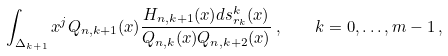<formula> <loc_0><loc_0><loc_500><loc_500>\int _ { \Delta _ { k + 1 } } x ^ { j } Q _ { { n } , k + 1 } ( x ) \frac { H _ { { n } , k + 1 } ( x ) d s _ { r _ { k } } ^ { k } ( x ) } { Q _ { { n } , k } ( x ) Q _ { { n } , k + 2 } ( x ) } \, , \quad k = 0 , \dots , m - 1 \, ,</formula> 